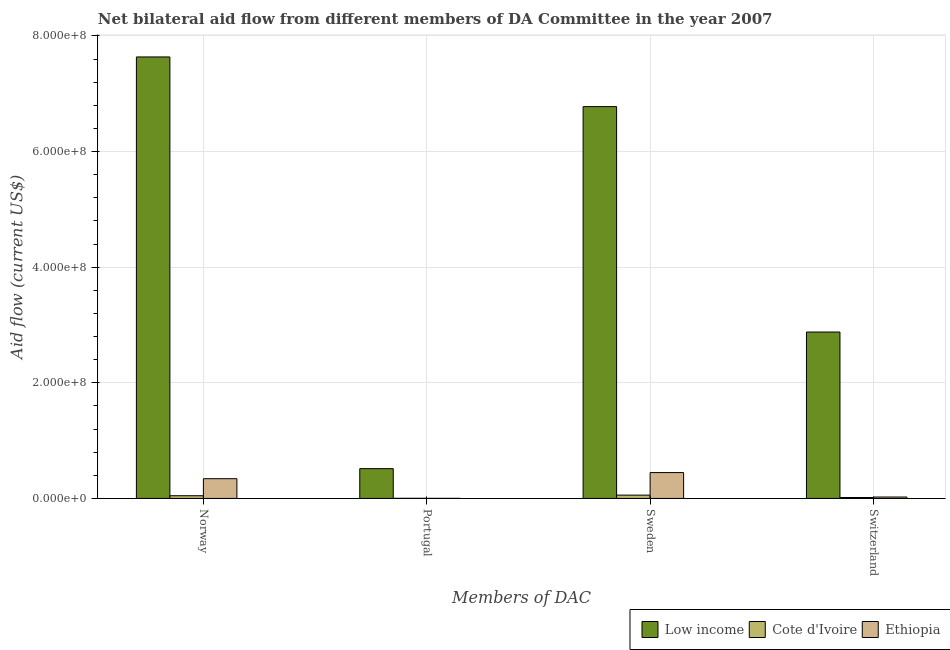How many different coloured bars are there?
Offer a terse response. 3. Are the number of bars on each tick of the X-axis equal?
Offer a terse response. Yes. What is the amount of aid given by sweden in Low income?
Your answer should be very brief. 6.78e+08. Across all countries, what is the maximum amount of aid given by norway?
Keep it short and to the point. 7.64e+08. Across all countries, what is the minimum amount of aid given by switzerland?
Make the answer very short. 1.59e+06. In which country was the amount of aid given by sweden maximum?
Provide a succinct answer. Low income. In which country was the amount of aid given by sweden minimum?
Provide a succinct answer. Cote d'Ivoire. What is the total amount of aid given by portugal in the graph?
Your response must be concise. 5.19e+07. What is the difference between the amount of aid given by portugal in Ethiopia and that in Cote d'Ivoire?
Ensure brevity in your answer.  -7.00e+04. What is the difference between the amount of aid given by switzerland in Cote d'Ivoire and the amount of aid given by sweden in Low income?
Provide a succinct answer. -6.76e+08. What is the average amount of aid given by switzerland per country?
Make the answer very short. 9.73e+07. What is the difference between the amount of aid given by portugal and amount of aid given by norway in Ethiopia?
Offer a very short reply. -3.40e+07. What is the ratio of the amount of aid given by sweden in Ethiopia to that in Cote d'Ivoire?
Your answer should be very brief. 7.79. Is the difference between the amount of aid given by portugal in Ethiopia and Cote d'Ivoire greater than the difference between the amount of aid given by norway in Ethiopia and Cote d'Ivoire?
Keep it short and to the point. No. What is the difference between the highest and the second highest amount of aid given by norway?
Your answer should be compact. 7.30e+08. What is the difference between the highest and the lowest amount of aid given by portugal?
Your response must be concise. 5.14e+07. In how many countries, is the amount of aid given by switzerland greater than the average amount of aid given by switzerland taken over all countries?
Make the answer very short. 1. Is the sum of the amount of aid given by norway in Ethiopia and Cote d'Ivoire greater than the maximum amount of aid given by portugal across all countries?
Make the answer very short. No. What does the 2nd bar from the left in Norway represents?
Make the answer very short. Cote d'Ivoire. What does the 2nd bar from the right in Sweden represents?
Make the answer very short. Cote d'Ivoire. How many bars are there?
Your answer should be compact. 12. What is the difference between two consecutive major ticks on the Y-axis?
Offer a very short reply. 2.00e+08. Does the graph contain any zero values?
Your answer should be compact. No. Does the graph contain grids?
Your answer should be very brief. Yes. How are the legend labels stacked?
Ensure brevity in your answer.  Horizontal. What is the title of the graph?
Give a very brief answer. Net bilateral aid flow from different members of DA Committee in the year 2007. Does "Kuwait" appear as one of the legend labels in the graph?
Your response must be concise. No. What is the label or title of the X-axis?
Your response must be concise. Members of DAC. What is the Aid flow (current US$) of Low income in Norway?
Your response must be concise. 7.64e+08. What is the Aid flow (current US$) in Cote d'Ivoire in Norway?
Your answer should be compact. 4.67e+06. What is the Aid flow (current US$) in Ethiopia in Norway?
Your answer should be very brief. 3.41e+07. What is the Aid flow (current US$) in Low income in Portugal?
Ensure brevity in your answer.  5.16e+07. What is the Aid flow (current US$) in Cote d'Ivoire in Portugal?
Provide a succinct answer. 2.00e+05. What is the Aid flow (current US$) in Low income in Sweden?
Your answer should be very brief. 6.78e+08. What is the Aid flow (current US$) of Cote d'Ivoire in Sweden?
Make the answer very short. 5.74e+06. What is the Aid flow (current US$) in Ethiopia in Sweden?
Provide a short and direct response. 4.47e+07. What is the Aid flow (current US$) in Low income in Switzerland?
Offer a very short reply. 2.88e+08. What is the Aid flow (current US$) in Cote d'Ivoire in Switzerland?
Keep it short and to the point. 1.59e+06. What is the Aid flow (current US$) in Ethiopia in Switzerland?
Provide a succinct answer. 2.43e+06. Across all Members of DAC, what is the maximum Aid flow (current US$) in Low income?
Ensure brevity in your answer.  7.64e+08. Across all Members of DAC, what is the maximum Aid flow (current US$) of Cote d'Ivoire?
Your answer should be very brief. 5.74e+06. Across all Members of DAC, what is the maximum Aid flow (current US$) in Ethiopia?
Your answer should be compact. 4.47e+07. Across all Members of DAC, what is the minimum Aid flow (current US$) in Low income?
Give a very brief answer. 5.16e+07. Across all Members of DAC, what is the minimum Aid flow (current US$) in Cote d'Ivoire?
Your answer should be compact. 2.00e+05. Across all Members of DAC, what is the minimum Aid flow (current US$) of Ethiopia?
Your response must be concise. 1.30e+05. What is the total Aid flow (current US$) in Low income in the graph?
Provide a short and direct response. 1.78e+09. What is the total Aid flow (current US$) of Cote d'Ivoire in the graph?
Provide a succinct answer. 1.22e+07. What is the total Aid flow (current US$) in Ethiopia in the graph?
Your answer should be very brief. 8.14e+07. What is the difference between the Aid flow (current US$) in Low income in Norway and that in Portugal?
Provide a succinct answer. 7.12e+08. What is the difference between the Aid flow (current US$) of Cote d'Ivoire in Norway and that in Portugal?
Give a very brief answer. 4.47e+06. What is the difference between the Aid flow (current US$) in Ethiopia in Norway and that in Portugal?
Your answer should be compact. 3.40e+07. What is the difference between the Aid flow (current US$) in Low income in Norway and that in Sweden?
Give a very brief answer. 8.59e+07. What is the difference between the Aid flow (current US$) in Cote d'Ivoire in Norway and that in Sweden?
Offer a terse response. -1.07e+06. What is the difference between the Aid flow (current US$) in Ethiopia in Norway and that in Sweden?
Give a very brief answer. -1.06e+07. What is the difference between the Aid flow (current US$) in Low income in Norway and that in Switzerland?
Ensure brevity in your answer.  4.76e+08. What is the difference between the Aid flow (current US$) of Cote d'Ivoire in Norway and that in Switzerland?
Provide a succinct answer. 3.08e+06. What is the difference between the Aid flow (current US$) in Ethiopia in Norway and that in Switzerland?
Your answer should be compact. 3.17e+07. What is the difference between the Aid flow (current US$) of Low income in Portugal and that in Sweden?
Your answer should be very brief. -6.26e+08. What is the difference between the Aid flow (current US$) of Cote d'Ivoire in Portugal and that in Sweden?
Make the answer very short. -5.54e+06. What is the difference between the Aid flow (current US$) of Ethiopia in Portugal and that in Sweden?
Give a very brief answer. -4.46e+07. What is the difference between the Aid flow (current US$) in Low income in Portugal and that in Switzerland?
Make the answer very short. -2.36e+08. What is the difference between the Aid flow (current US$) of Cote d'Ivoire in Portugal and that in Switzerland?
Give a very brief answer. -1.39e+06. What is the difference between the Aid flow (current US$) of Ethiopia in Portugal and that in Switzerland?
Provide a succinct answer. -2.30e+06. What is the difference between the Aid flow (current US$) in Low income in Sweden and that in Switzerland?
Provide a short and direct response. 3.90e+08. What is the difference between the Aid flow (current US$) of Cote d'Ivoire in Sweden and that in Switzerland?
Keep it short and to the point. 4.15e+06. What is the difference between the Aid flow (current US$) in Ethiopia in Sweden and that in Switzerland?
Provide a succinct answer. 4.23e+07. What is the difference between the Aid flow (current US$) of Low income in Norway and the Aid flow (current US$) of Cote d'Ivoire in Portugal?
Provide a succinct answer. 7.64e+08. What is the difference between the Aid flow (current US$) in Low income in Norway and the Aid flow (current US$) in Ethiopia in Portugal?
Keep it short and to the point. 7.64e+08. What is the difference between the Aid flow (current US$) of Cote d'Ivoire in Norway and the Aid flow (current US$) of Ethiopia in Portugal?
Ensure brevity in your answer.  4.54e+06. What is the difference between the Aid flow (current US$) of Low income in Norway and the Aid flow (current US$) of Cote d'Ivoire in Sweden?
Offer a terse response. 7.58e+08. What is the difference between the Aid flow (current US$) in Low income in Norway and the Aid flow (current US$) in Ethiopia in Sweden?
Give a very brief answer. 7.19e+08. What is the difference between the Aid flow (current US$) of Cote d'Ivoire in Norway and the Aid flow (current US$) of Ethiopia in Sweden?
Offer a very short reply. -4.00e+07. What is the difference between the Aid flow (current US$) in Low income in Norway and the Aid flow (current US$) in Cote d'Ivoire in Switzerland?
Provide a short and direct response. 7.62e+08. What is the difference between the Aid flow (current US$) in Low income in Norway and the Aid flow (current US$) in Ethiopia in Switzerland?
Your answer should be compact. 7.61e+08. What is the difference between the Aid flow (current US$) in Cote d'Ivoire in Norway and the Aid flow (current US$) in Ethiopia in Switzerland?
Keep it short and to the point. 2.24e+06. What is the difference between the Aid flow (current US$) of Low income in Portugal and the Aid flow (current US$) of Cote d'Ivoire in Sweden?
Make the answer very short. 4.58e+07. What is the difference between the Aid flow (current US$) of Low income in Portugal and the Aid flow (current US$) of Ethiopia in Sweden?
Offer a very short reply. 6.84e+06. What is the difference between the Aid flow (current US$) in Cote d'Ivoire in Portugal and the Aid flow (current US$) in Ethiopia in Sweden?
Provide a succinct answer. -4.45e+07. What is the difference between the Aid flow (current US$) of Low income in Portugal and the Aid flow (current US$) of Cote d'Ivoire in Switzerland?
Offer a very short reply. 5.00e+07. What is the difference between the Aid flow (current US$) of Low income in Portugal and the Aid flow (current US$) of Ethiopia in Switzerland?
Give a very brief answer. 4.91e+07. What is the difference between the Aid flow (current US$) of Cote d'Ivoire in Portugal and the Aid flow (current US$) of Ethiopia in Switzerland?
Keep it short and to the point. -2.23e+06. What is the difference between the Aid flow (current US$) in Low income in Sweden and the Aid flow (current US$) in Cote d'Ivoire in Switzerland?
Give a very brief answer. 6.76e+08. What is the difference between the Aid flow (current US$) in Low income in Sweden and the Aid flow (current US$) in Ethiopia in Switzerland?
Ensure brevity in your answer.  6.75e+08. What is the difference between the Aid flow (current US$) in Cote d'Ivoire in Sweden and the Aid flow (current US$) in Ethiopia in Switzerland?
Offer a very short reply. 3.31e+06. What is the average Aid flow (current US$) of Low income per Members of DAC?
Make the answer very short. 4.45e+08. What is the average Aid flow (current US$) in Cote d'Ivoire per Members of DAC?
Provide a short and direct response. 3.05e+06. What is the average Aid flow (current US$) in Ethiopia per Members of DAC?
Your answer should be very brief. 2.04e+07. What is the difference between the Aid flow (current US$) in Low income and Aid flow (current US$) in Cote d'Ivoire in Norway?
Ensure brevity in your answer.  7.59e+08. What is the difference between the Aid flow (current US$) of Low income and Aid flow (current US$) of Ethiopia in Norway?
Your answer should be very brief. 7.30e+08. What is the difference between the Aid flow (current US$) in Cote d'Ivoire and Aid flow (current US$) in Ethiopia in Norway?
Your response must be concise. -2.95e+07. What is the difference between the Aid flow (current US$) of Low income and Aid flow (current US$) of Cote d'Ivoire in Portugal?
Offer a terse response. 5.14e+07. What is the difference between the Aid flow (current US$) of Low income and Aid flow (current US$) of Ethiopia in Portugal?
Provide a succinct answer. 5.14e+07. What is the difference between the Aid flow (current US$) in Cote d'Ivoire and Aid flow (current US$) in Ethiopia in Portugal?
Ensure brevity in your answer.  7.00e+04. What is the difference between the Aid flow (current US$) of Low income and Aid flow (current US$) of Cote d'Ivoire in Sweden?
Give a very brief answer. 6.72e+08. What is the difference between the Aid flow (current US$) in Low income and Aid flow (current US$) in Ethiopia in Sweden?
Provide a short and direct response. 6.33e+08. What is the difference between the Aid flow (current US$) of Cote d'Ivoire and Aid flow (current US$) of Ethiopia in Sweden?
Give a very brief answer. -3.90e+07. What is the difference between the Aid flow (current US$) of Low income and Aid flow (current US$) of Cote d'Ivoire in Switzerland?
Give a very brief answer. 2.86e+08. What is the difference between the Aid flow (current US$) of Low income and Aid flow (current US$) of Ethiopia in Switzerland?
Keep it short and to the point. 2.85e+08. What is the difference between the Aid flow (current US$) of Cote d'Ivoire and Aid flow (current US$) of Ethiopia in Switzerland?
Your response must be concise. -8.40e+05. What is the ratio of the Aid flow (current US$) in Low income in Norway to that in Portugal?
Provide a succinct answer. 14.81. What is the ratio of the Aid flow (current US$) of Cote d'Ivoire in Norway to that in Portugal?
Offer a very short reply. 23.35. What is the ratio of the Aid flow (current US$) of Ethiopia in Norway to that in Portugal?
Offer a very short reply. 262.62. What is the ratio of the Aid flow (current US$) in Low income in Norway to that in Sweden?
Offer a very short reply. 1.13. What is the ratio of the Aid flow (current US$) in Cote d'Ivoire in Norway to that in Sweden?
Ensure brevity in your answer.  0.81. What is the ratio of the Aid flow (current US$) of Ethiopia in Norway to that in Sweden?
Offer a terse response. 0.76. What is the ratio of the Aid flow (current US$) of Low income in Norway to that in Switzerland?
Keep it short and to the point. 2.65. What is the ratio of the Aid flow (current US$) in Cote d'Ivoire in Norway to that in Switzerland?
Your answer should be very brief. 2.94. What is the ratio of the Aid flow (current US$) in Ethiopia in Norway to that in Switzerland?
Your answer should be compact. 14.05. What is the ratio of the Aid flow (current US$) of Low income in Portugal to that in Sweden?
Give a very brief answer. 0.08. What is the ratio of the Aid flow (current US$) in Cote d'Ivoire in Portugal to that in Sweden?
Ensure brevity in your answer.  0.03. What is the ratio of the Aid flow (current US$) of Ethiopia in Portugal to that in Sweden?
Offer a very short reply. 0. What is the ratio of the Aid flow (current US$) of Low income in Portugal to that in Switzerland?
Give a very brief answer. 0.18. What is the ratio of the Aid flow (current US$) in Cote d'Ivoire in Portugal to that in Switzerland?
Your response must be concise. 0.13. What is the ratio of the Aid flow (current US$) in Ethiopia in Portugal to that in Switzerland?
Your answer should be very brief. 0.05. What is the ratio of the Aid flow (current US$) of Low income in Sweden to that in Switzerland?
Provide a short and direct response. 2.35. What is the ratio of the Aid flow (current US$) in Cote d'Ivoire in Sweden to that in Switzerland?
Ensure brevity in your answer.  3.61. What is the ratio of the Aid flow (current US$) in Ethiopia in Sweden to that in Switzerland?
Offer a terse response. 18.4. What is the difference between the highest and the second highest Aid flow (current US$) in Low income?
Your answer should be compact. 8.59e+07. What is the difference between the highest and the second highest Aid flow (current US$) of Cote d'Ivoire?
Make the answer very short. 1.07e+06. What is the difference between the highest and the second highest Aid flow (current US$) in Ethiopia?
Your response must be concise. 1.06e+07. What is the difference between the highest and the lowest Aid flow (current US$) in Low income?
Make the answer very short. 7.12e+08. What is the difference between the highest and the lowest Aid flow (current US$) of Cote d'Ivoire?
Provide a succinct answer. 5.54e+06. What is the difference between the highest and the lowest Aid flow (current US$) of Ethiopia?
Offer a very short reply. 4.46e+07. 